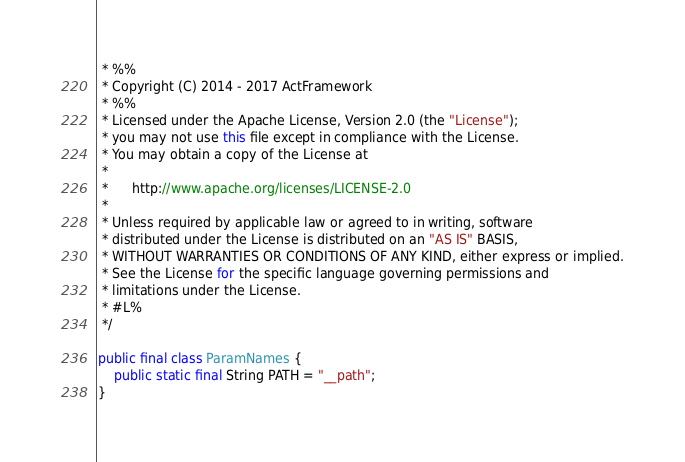<code> <loc_0><loc_0><loc_500><loc_500><_Java_> * %%
 * Copyright (C) 2014 - 2017 ActFramework
 * %%
 * Licensed under the Apache License, Version 2.0 (the "License");
 * you may not use this file except in compliance with the License.
 * You may obtain a copy of the License at
 * 
 *      http://www.apache.org/licenses/LICENSE-2.0
 * 
 * Unless required by applicable law or agreed to in writing, software
 * distributed under the License is distributed on an "AS IS" BASIS,
 * WITHOUT WARRANTIES OR CONDITIONS OF ANY KIND, either express or implied.
 * See the License for the specific language governing permissions and
 * limitations under the License.
 * #L%
 */

public final class ParamNames {
    public static final String PATH = "__path";
}
</code> 